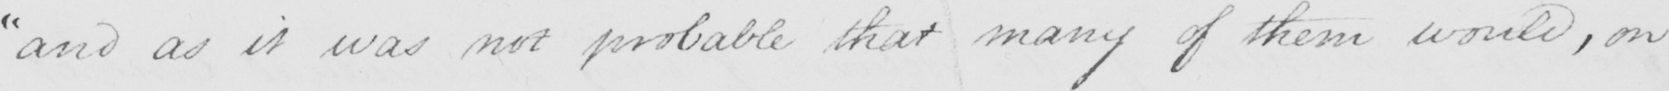What text is written in this handwritten line? " and as it was not probable that many of them would , on 